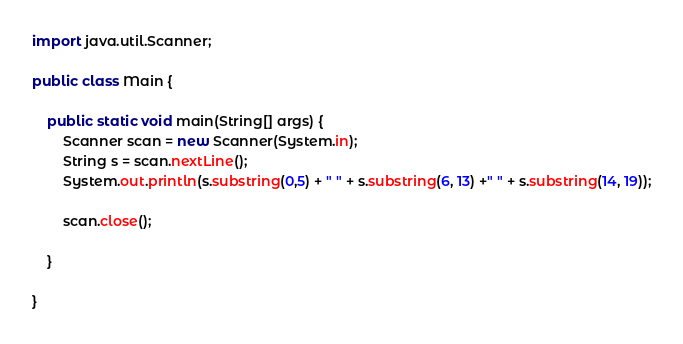Convert code to text. <code><loc_0><loc_0><loc_500><loc_500><_Java_>import java.util.Scanner;

public class Main {

	public static void main(String[] args) {
		Scanner scan = new Scanner(System.in);
		String s = scan.nextLine();
		System.out.println(s.substring(0,5) + " " + s.substring(6, 13) +" " + s.substring(14, 19));
		
		scan.close();

	}

}
</code> 